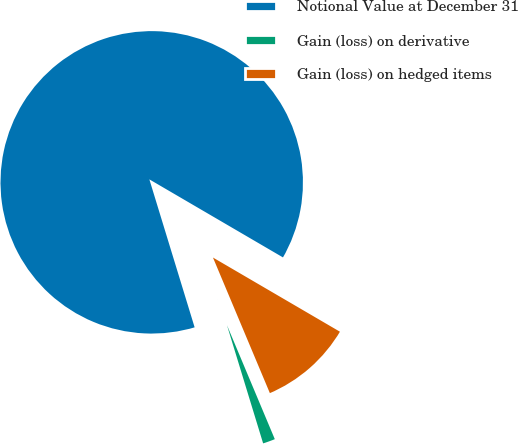Convert chart to OTSL. <chart><loc_0><loc_0><loc_500><loc_500><pie_chart><fcel>Notional Value at December 31<fcel>Gain (loss) on derivative<fcel>Gain (loss) on hedged items<nl><fcel>88.14%<fcel>1.6%<fcel>10.26%<nl></chart> 